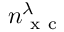<formula> <loc_0><loc_0><loc_500><loc_500>n _ { x c } ^ { \lambda }</formula> 